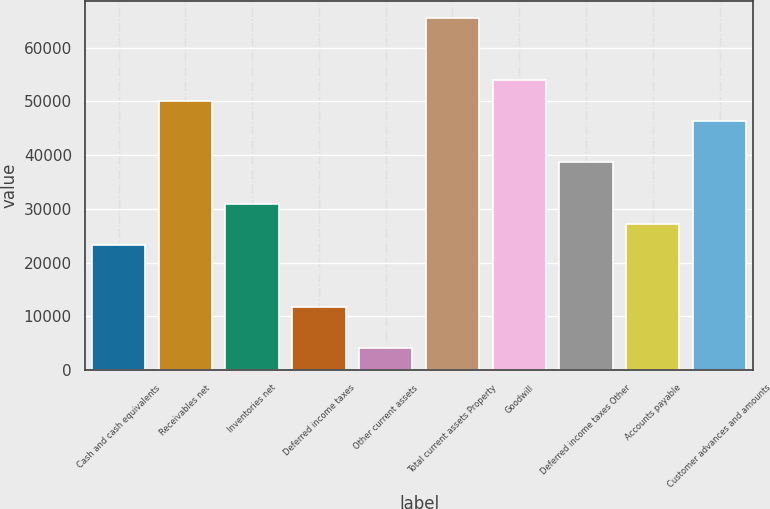Convert chart. <chart><loc_0><loc_0><loc_500><loc_500><bar_chart><fcel>Cash and cash equivalents<fcel>Receivables net<fcel>Inventories net<fcel>Deferred income taxes<fcel>Other current assets<fcel>Total current assets Property<fcel>Goodwill<fcel>Deferred income taxes Other<fcel>Accounts payable<fcel>Customer advances and amounts<nl><fcel>23322.6<fcel>50157.8<fcel>30989.8<fcel>11821.8<fcel>4154.6<fcel>65492.2<fcel>53991.4<fcel>38657<fcel>27156.2<fcel>46324.2<nl></chart> 